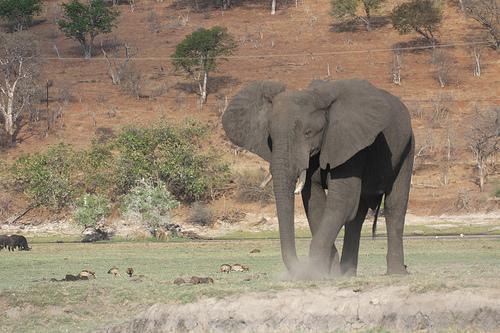How many elephants are there?
Give a very brief answer. 1. How many ears does the elephant have?
Give a very brief answer. 2. How many legs does the elephant have?
Give a very brief answer. 4. How many of the elephant's eyes can we see?
Give a very brief answer. 1. 